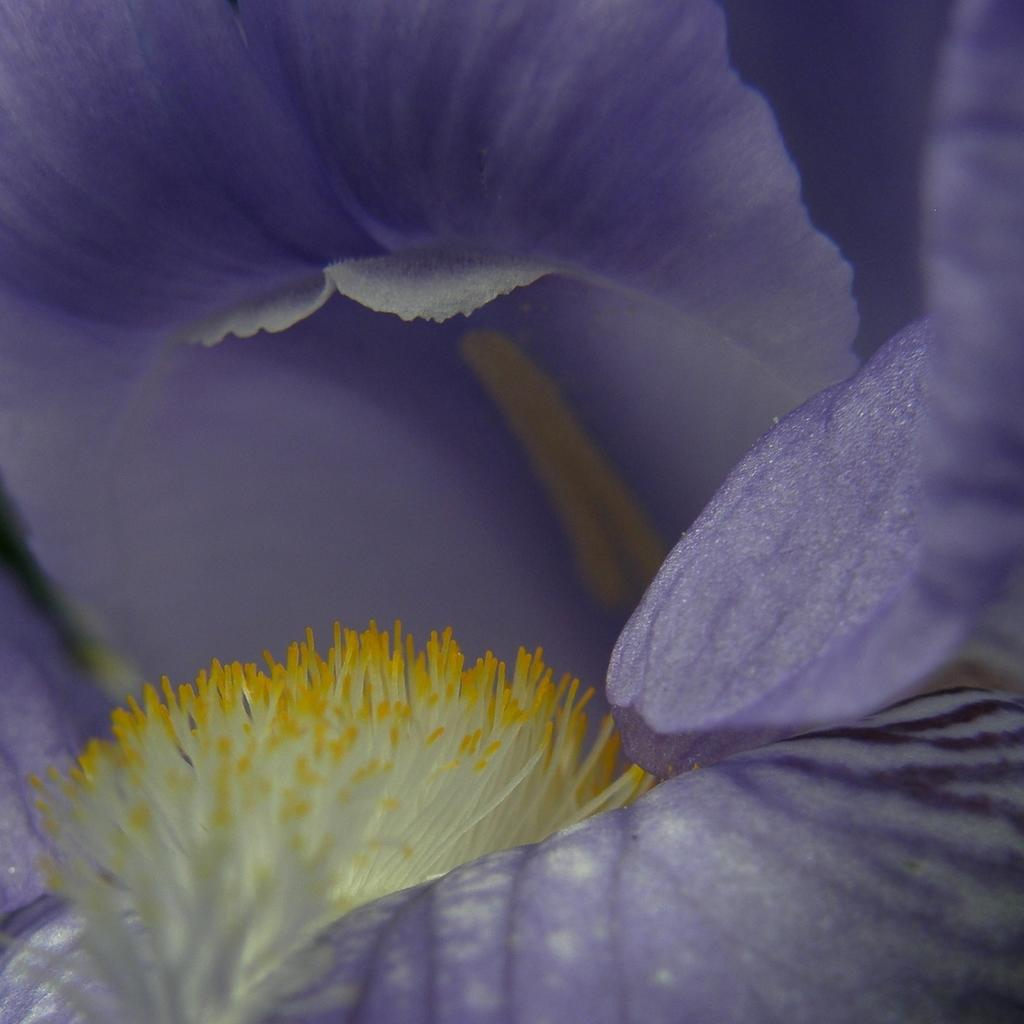What is the main subject of the image? There is a flower in the image. What part of the flower is visible in the image? There are petals in the image. What color is the background of the image? The background of the image is purple. What type of humor can be seen in the image? There is no humor present in the image; it features a flower and its petals against a purple background. Can you tell me how many goats are in the image? There are no goats present in the image; it features a flower and its petals against a purple background. 